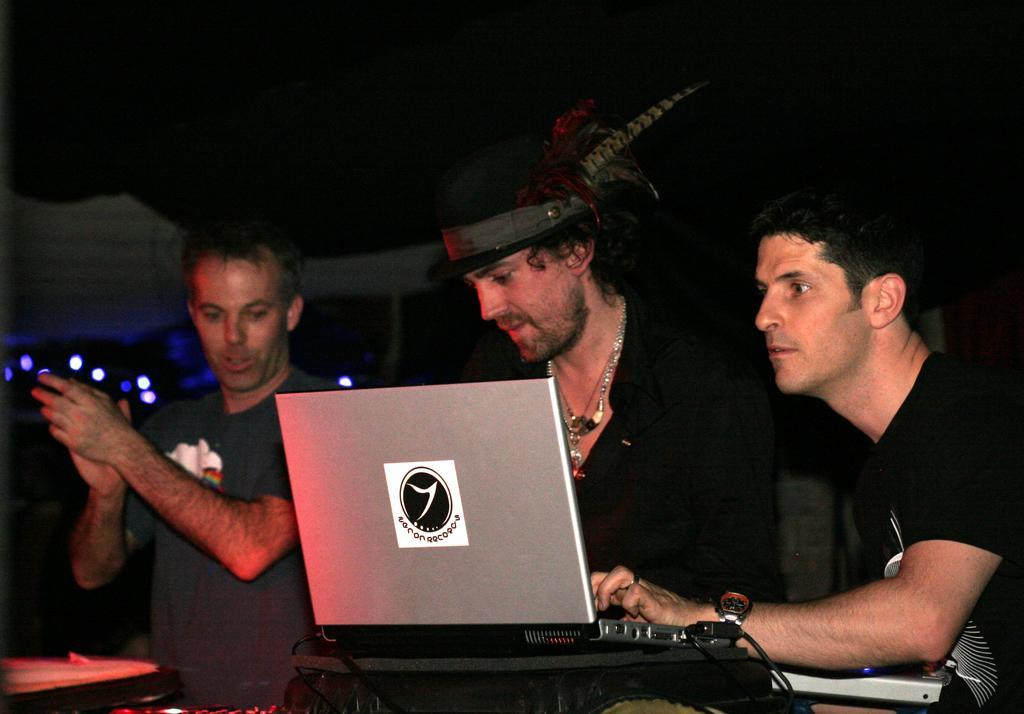How many men are in the image? There are three men in the image. What are the men wearing? The men are wearing clothes. Can you describe the attire of the middle man? The middle man is wearing a neck chain and a hat. What electronic device is visible in the image? There is a laptop in the image. What type of wires are visible in the image? Cable wires are visible in the image. What type of lighting is present in the image? Lights are present in the image. How would you describe the background of the image? The background of the image is dark. What type of stew is being prepared by the men in the image? There is no indication of any stew being prepared in the image. What hobbies do the men's sisters have, as seen in the image? There is no mention of sisters or their hobbies in the image. 